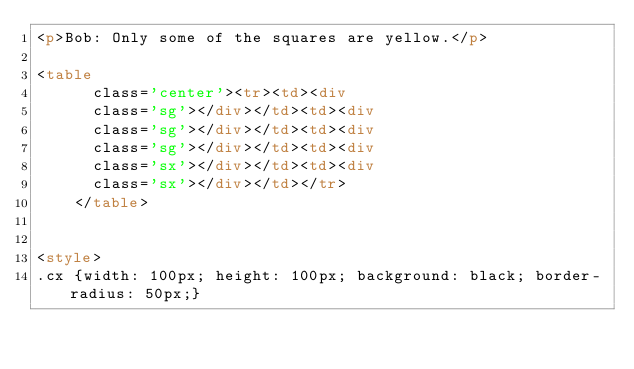<code> <loc_0><loc_0><loc_500><loc_500><_HTML_><p>Bob: Only some of the squares are yellow.</p>

<table
      class='center'><tr><td><div
      class='sg'></div></td><td><div
      class='sg'></div></td><td><div
      class='sg'></div></td><td><div
      class='sx'></div></td><td><div
      class='sx'></div></td></tr>
    </table>


<style>
.cx {width: 100px; height: 100px; background: black; border-radius: 50px;}</code> 